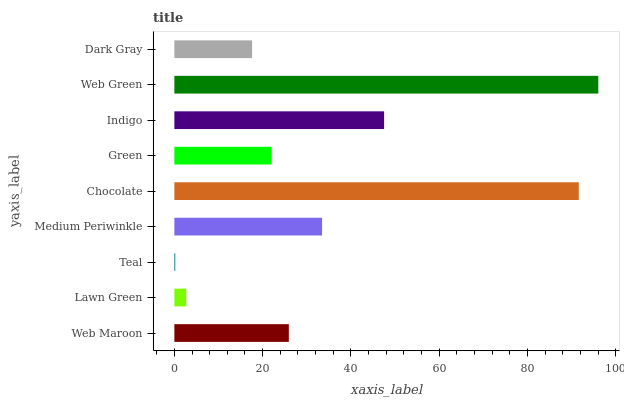Is Teal the minimum?
Answer yes or no. Yes. Is Web Green the maximum?
Answer yes or no. Yes. Is Lawn Green the minimum?
Answer yes or no. No. Is Lawn Green the maximum?
Answer yes or no. No. Is Web Maroon greater than Lawn Green?
Answer yes or no. Yes. Is Lawn Green less than Web Maroon?
Answer yes or no. Yes. Is Lawn Green greater than Web Maroon?
Answer yes or no. No. Is Web Maroon less than Lawn Green?
Answer yes or no. No. Is Web Maroon the high median?
Answer yes or no. Yes. Is Web Maroon the low median?
Answer yes or no. Yes. Is Chocolate the high median?
Answer yes or no. No. Is Lawn Green the low median?
Answer yes or no. No. 